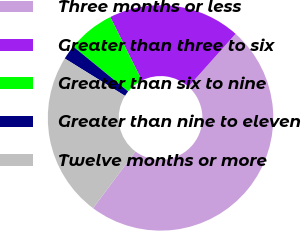<chart> <loc_0><loc_0><loc_500><loc_500><pie_chart><fcel>Three months or less<fcel>Greater than three to six<fcel>Greater than six to nine<fcel>Greater than nine to eleven<fcel>Twelve months or more<nl><fcel>48.61%<fcel>18.96%<fcel>6.73%<fcel>2.07%<fcel>23.62%<nl></chart> 